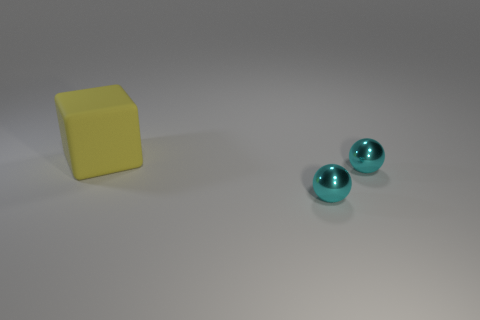Is the number of matte cubes that are in front of the large yellow block less than the number of tiny cyan metal balls?
Provide a short and direct response. Yes. How many other things are the same shape as the large yellow thing?
Make the answer very short. 0. How many green things are matte objects or small metal balls?
Offer a very short reply. 0. Are there the same number of rubber things behind the large matte block and small blue rubber things?
Provide a succinct answer. Yes. How many other objects are there of the same size as the rubber object?
Offer a terse response. 0. Is there a small ball that has the same color as the block?
Give a very brief answer. No. There is a matte block; what number of yellow things are to the right of it?
Ensure brevity in your answer.  0. How many other large yellow things are the same material as the large yellow object?
Give a very brief answer. 0. Is there a yellow matte ball?
Your answer should be compact. No. What is the color of the block?
Your answer should be compact. Yellow. 